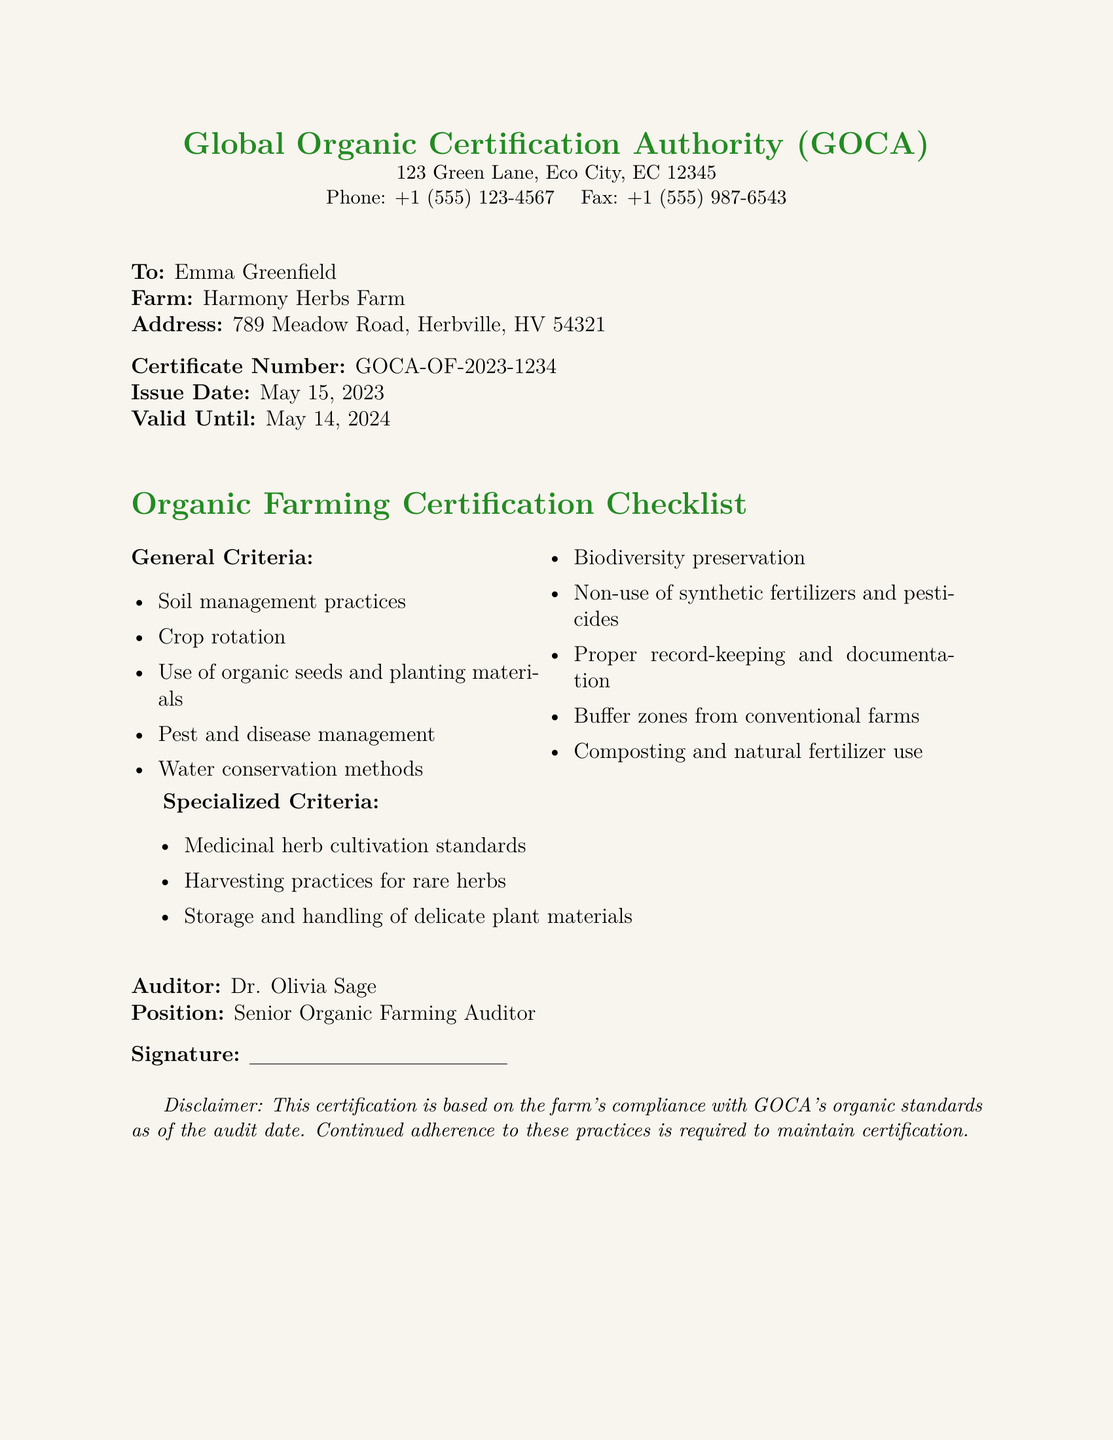What is the certificate number? The certificate number is clearly stated in the document, which is a unique identifier for this certification.
Answer: GOCA-OF-2023-1234 Who issued the certification? The organization that issued the certification is mentioned at the top of the document.
Answer: Global Organic Certification Authority (GOCA) What is the issue date of the certificate? The issue date is explicitly listed in the document and indicates when the certification was granted.
Answer: May 15, 2023 What criteria includes pest management? Pest management is one of the general criteria outlined in the checklist section of the document.
Answer: Pest and disease management Who is the auditor? The auditor responsible for this certification is named at the bottom of the document.
Answer: Dr. Olivia Sage What is the validity period of the certificate? The document specifies a validity period, showing how long the certification remains effective.
Answer: May 14, 2024 What specialized criteria is mentioned? The specialized criteria focuses specifically on aspects of growing particular types of plants.
Answer: Medicinal herb cultivation standards What farm is being certified? The name of the farm receiving the certification is mentioned in the recipient details of the document.
Answer: Harmony Herbs Farm 